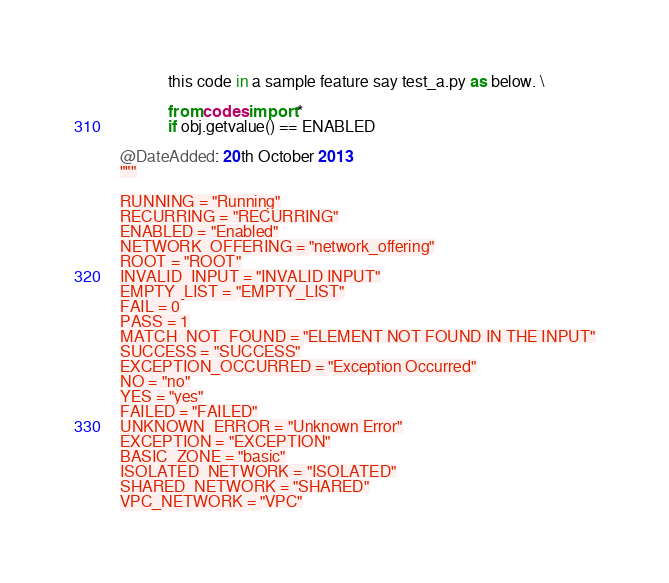<code> <loc_0><loc_0><loc_500><loc_500><_Python_>            this code in a sample feature say test_a.py as below. \

            from codes import *
            if obj.getvalue() == ENABLED

@DateAdded: 20th October 2013
"""

RUNNING = "Running"
RECURRING = "RECURRING"
ENABLED = "Enabled"
NETWORK_OFFERING = "network_offering"
ROOT = "ROOT"
INVALID_INPUT = "INVALID INPUT"
EMPTY_LIST = "EMPTY_LIST"
FAIL = 0
PASS = 1
MATCH_NOT_FOUND = "ELEMENT NOT FOUND IN THE INPUT"
SUCCESS = "SUCCESS"
EXCEPTION_OCCURRED = "Exception Occurred"
NO = "no"
YES = "yes"
FAILED = "FAILED"
UNKNOWN_ERROR = "Unknown Error"
EXCEPTION = "EXCEPTION"
BASIC_ZONE = "basic"
ISOLATED_NETWORK = "ISOLATED"
SHARED_NETWORK = "SHARED"
VPC_NETWORK = "VPC"
</code> 